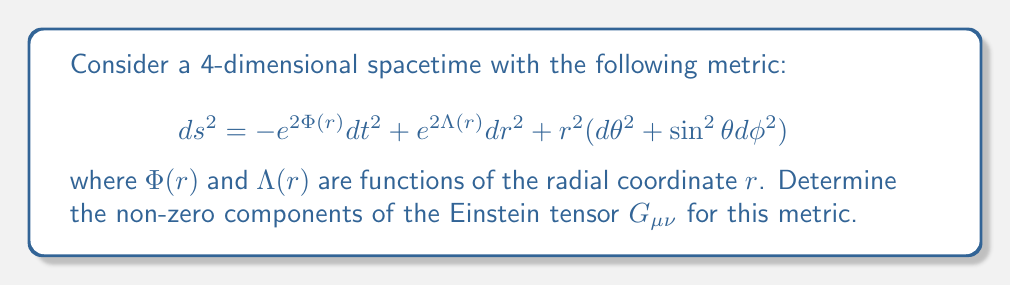Help me with this question. To determine the Einstein tensor, we'll follow these steps:

1) First, calculate the Christoffel symbols $\Gamma^\alpha_{\mu\nu}$.
2) Use the Christoffel symbols to compute the Riemann tensor $R^\alpha_{\beta\mu\nu}$.
3) Contract the Riemann tensor to get the Ricci tensor $R_{\mu\nu}$.
4) Calculate the Ricci scalar $R$.
5) Finally, compute the Einstein tensor $G_{\mu\nu} = R_{\mu\nu} - \frac{1}{2}g_{\mu\nu}R$.

Step 1: Christoffel symbols

The non-zero Christoffel symbols are:

$$\Gamma^t_{tr} = \Phi'(r)$$
$$\Gamma^r_{tt} = e^{2(\Phi-\Lambda)}\Phi'(r)$$
$$\Gamma^r_{rr} = \Lambda'(r)$$
$$\Gamma^r_{\theta\theta} = -re^{-2\Lambda}$$
$$\Gamma^r_{\phi\phi} = -re^{-2\Lambda}\sin^2\theta$$
$$\Gamma^\theta_{r\theta} = \Gamma^\phi_{r\phi} = \frac{1}{r}$$
$$\Gamma^\phi_{\theta\phi} = \cot\theta$$

Step 2: Riemann tensor

The non-zero components of the Riemann tensor are:

$$R^t_{rtr} = \Phi''(r) + [\Phi'(r)]^2 - \Phi'(r)\Lambda'(r)$$
$$R^\theta_{r\theta r} = R^\phi_{r\phi r} = -e^{-2\Lambda}[\Lambda'(r) + \frac{1}{r}(\Phi'(r) - \Lambda'(r))]$$
$$R^\theta_{\phi\theta\phi} = (1 - e^{-2\Lambda})\sin^2\theta$$

Step 3: Ricci tensor

The non-zero components of the Ricci tensor are:

$$R_{tt} = e^{2(\Phi-\Lambda)}[\Phi''(r) + [\Phi'(r)]^2 - \Phi'(r)\Lambda'(r) + \frac{2}{r}\Phi'(r)]$$
$$R_{rr} = -\Phi''(r) - [\Phi'(r)]^2 + \Phi'(r)\Lambda'(r) + \frac{2}{r}\Lambda'(r)$$
$$R_{\theta\theta} = e^{-2\Lambda}[r(\Lambda'(r) - \Phi'(r)) - 1] + 1$$
$$R_{\phi\phi} = \sin^2\theta R_{\theta\theta}$$

Step 4: Ricci scalar

$$R = 2e^{-2\Lambda}[-\Phi''(r) - [\Phi'(r)]^2 + \Phi'(r)\Lambda'(r) + \frac{2}{r}(\Lambda'(r) - \Phi'(r)) + \frac{1}{r^2}(1 - e^{2\Lambda})]$$

Step 5: Einstein tensor

The non-zero components of the Einstein tensor are:

$$G_{tt} = e^{2\Phi}[e^{-2\Lambda}(\frac{2}{r}\Lambda'(r) + \frac{1}{r^2}(1 - e^{2\Lambda}))]$$
$$G_{rr} = e^{2\Lambda}[\frac{2}{r}\Phi'(r) - \frac{1}{r^2}(1 - e^{2\Lambda})]$$
$$G_{\theta\theta} = r^2e^{-2\Lambda}[\Phi''(r) + [\Phi'(r)]^2 - \Phi'(r)\Lambda'(r) + \frac{1}{r}(\Phi'(r) - \Lambda'(r))]$$
$$G_{\phi\phi} = \sin^2\theta G_{\theta\theta}$$
Answer: $G_{tt} = e^{2\Phi}[e^{-2\Lambda}(\frac{2}{r}\Lambda'(r) + \frac{1}{r^2}(1 - e^{2\Lambda}))]$
$G_{rr} = e^{2\Lambda}[\frac{2}{r}\Phi'(r) - \frac{1}{r^2}(1 - e^{2\Lambda})]$
$G_{\theta\theta} = r^2e^{-2\Lambda}[\Phi''(r) + [\Phi'(r)]^2 - \Phi'(r)\Lambda'(r) + \frac{1}{r}(\Phi'(r) - \Lambda'(r))]$
$G_{\phi\phi} = \sin^2\theta G_{\theta\theta}$ 